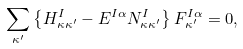<formula> <loc_0><loc_0><loc_500><loc_500>\sum _ { \kappa ^ { \prime } } \left \{ H ^ { I } _ { \kappa \kappa ^ { \prime } } - E ^ { I \alpha } N ^ { I } _ { \kappa \kappa ^ { \prime } } \right \} F ^ { I \alpha } _ { \kappa ^ { \prime } } = 0 ,</formula> 